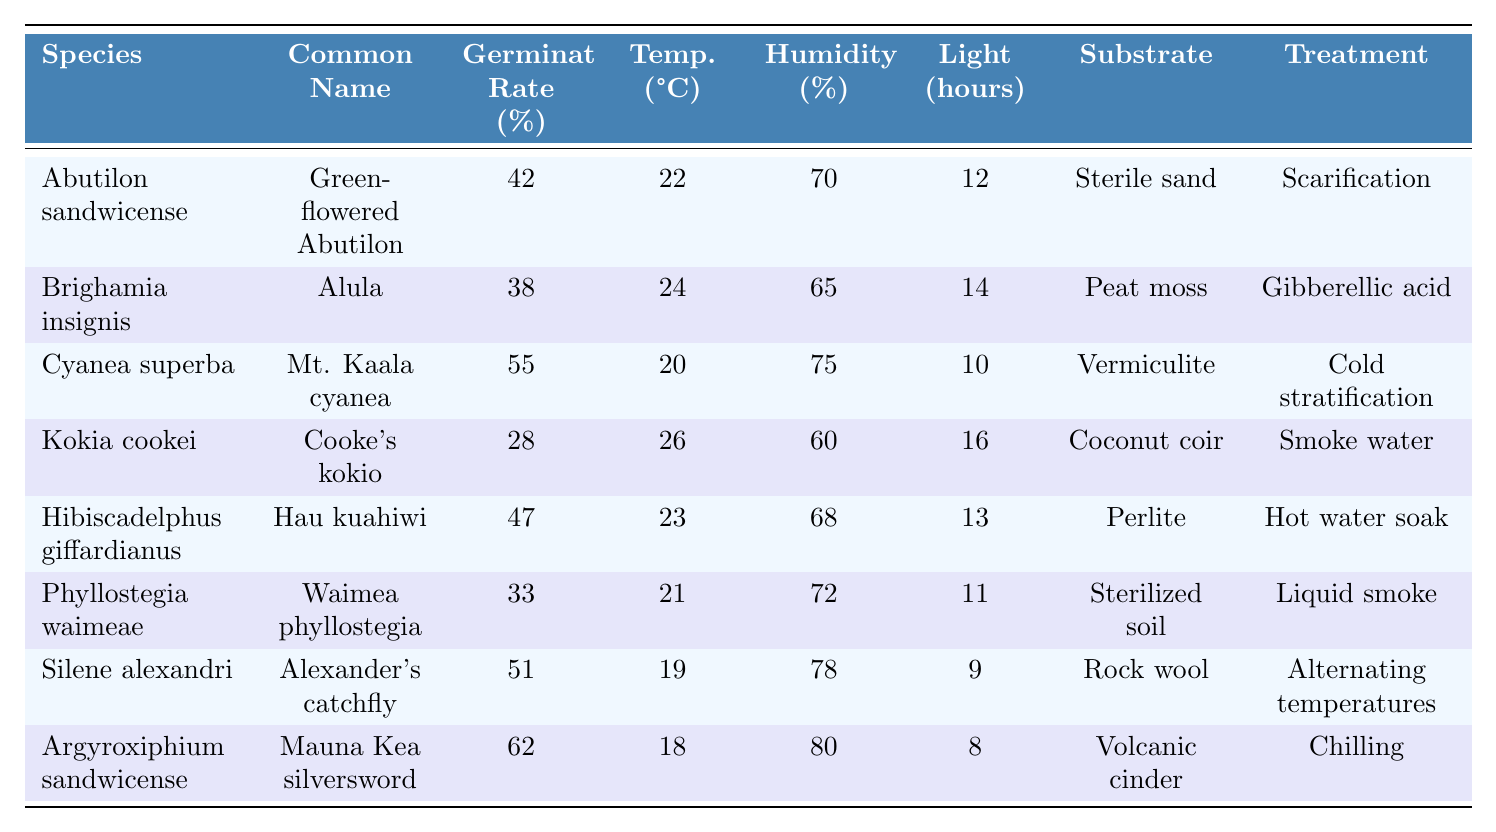What is the germination rate of Kokia cookei? The table indicates that the germination rate for Kokia cookei is specified under the "Germination Rate (%)" column. According to the data, it shows a rate of 28%.
Answer: 28% Which species has the highest germination rate? By examining the "Germination Rate (%)" values in the table, we can see that Argyroxiphium sandwicense has the highest rate at 62%.
Answer: Argyroxiphium sandwicense What is the average germination rate of all species listed? To find the average, we first sum all germination rates: 42 + 38 + 55 + 28 + 47 + 33 + 51 + 62 = 356. Then divide by the number of species (8): 356 / 8 = 44.5.
Answer: 44.5 Is the germination success rate higher for species that are treated with Gibberellic acid compared to those treated with Liquid smoke? For Brighamia insignis (Gibberellic acid), the germination rate is 38%, and for Phyllostegia waimeae (Liquid smoke), it is 33%. Since 38% is greater than 33%, the statement is true.
Answer: Yes What is the difference in germination rate between the species with the highest and lowest rates? From the table, the highest rate is 62% (Argyroxiphium sandwicense), and the lowest is 28% (Kokia cookei). The difference is: 62 - 28 = 34.
Answer: 34 How many species have a germination rate above 50%? Looking at the germination rates listed, we see Cyanea superba (55%), Silene alexandri (51%), and Argyroxiphium sandwicense (62%) are all above 50%. Counting these, there are three species.
Answer: 3 Which treatment applied to seeds resulted in the highest germination rate, according to the data? We can review the treatment associated with each germination rate. Argyroxiphium sandwicense, treated with chilling, achieved the highest germination rate of 62%.
Answer: Chilling Are there any species with a substrate type of "Sterile sand"? Referring to the "Substrate" column, the species Abutilon sandwicense is noted to use "Sterile sand." Therefore, the answer is yes.
Answer: Yes What is the relationship between humidity and germination rate for the species listed, based on the table? To examine the relationship, we can observe the values: Argyroxiphium sandwicense (80% humidity) has the highest germination rate (62%), while Kokia cookei (60% humidity) has the lowest rate (28%). This suggests that higher humidity correlates with higher germination rates.
Answer: Higher humidity may benefit germination rates 